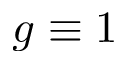<formula> <loc_0><loc_0><loc_500><loc_500>g \equiv 1</formula> 